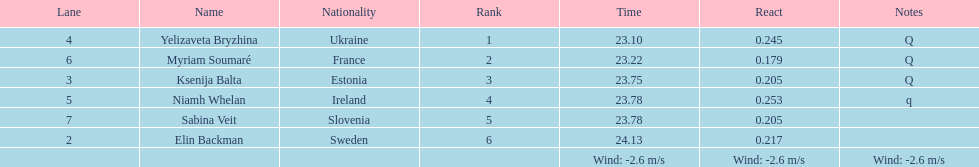Would you mind parsing the complete table? {'header': ['Lane', 'Name', 'Nationality', 'Rank', 'Time', 'React', 'Notes'], 'rows': [['4', 'Yelizaveta Bryzhina', 'Ukraine', '1', '23.10', '0.245', 'Q'], ['6', 'Myriam Soumaré', 'France', '2', '23.22', '0.179', 'Q'], ['3', 'Ksenija Balta', 'Estonia', '3', '23.75', '0.205', 'Q'], ['5', 'Niamh Whelan', 'Ireland', '4', '23.78', '0.253', 'q'], ['7', 'Sabina Veit', 'Slovenia', '5', '23.78', '0.205', ''], ['2', 'Elin Backman', 'Sweden', '6', '24.13', '0.217', ''], ['', '', '', '', 'Wind: -2.6\xa0m/s', 'Wind: -2.6\xa0m/s', 'Wind: -2.6\xa0m/s']]} The difference between yelizaveta bryzhina's time and ksenija balta's time? 0.65. 